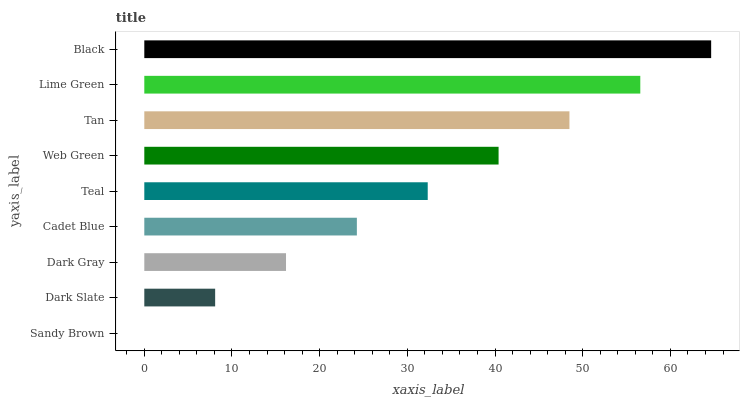Is Sandy Brown the minimum?
Answer yes or no. Yes. Is Black the maximum?
Answer yes or no. Yes. Is Dark Slate the minimum?
Answer yes or no. No. Is Dark Slate the maximum?
Answer yes or no. No. Is Dark Slate greater than Sandy Brown?
Answer yes or no. Yes. Is Sandy Brown less than Dark Slate?
Answer yes or no. Yes. Is Sandy Brown greater than Dark Slate?
Answer yes or no. No. Is Dark Slate less than Sandy Brown?
Answer yes or no. No. Is Teal the high median?
Answer yes or no. Yes. Is Teal the low median?
Answer yes or no. Yes. Is Tan the high median?
Answer yes or no. No. Is Dark Slate the low median?
Answer yes or no. No. 